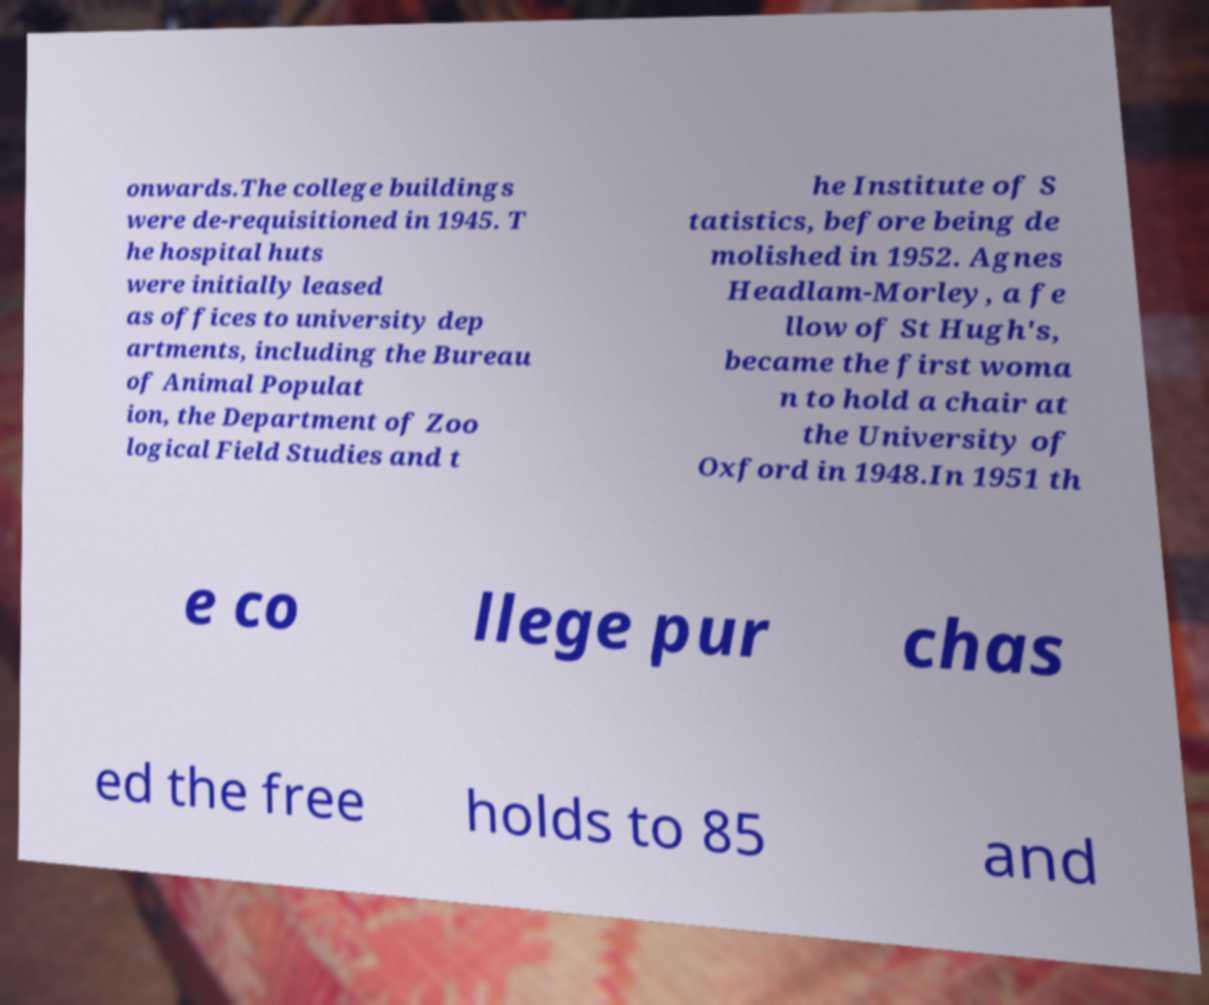Please identify and transcribe the text found in this image. onwards.The college buildings were de-requisitioned in 1945. T he hospital huts were initially leased as offices to university dep artments, including the Bureau of Animal Populat ion, the Department of Zoo logical Field Studies and t he Institute of S tatistics, before being de molished in 1952. Agnes Headlam-Morley, a fe llow of St Hugh's, became the first woma n to hold a chair at the University of Oxford in 1948.In 1951 th e co llege pur chas ed the free holds to 85 and 